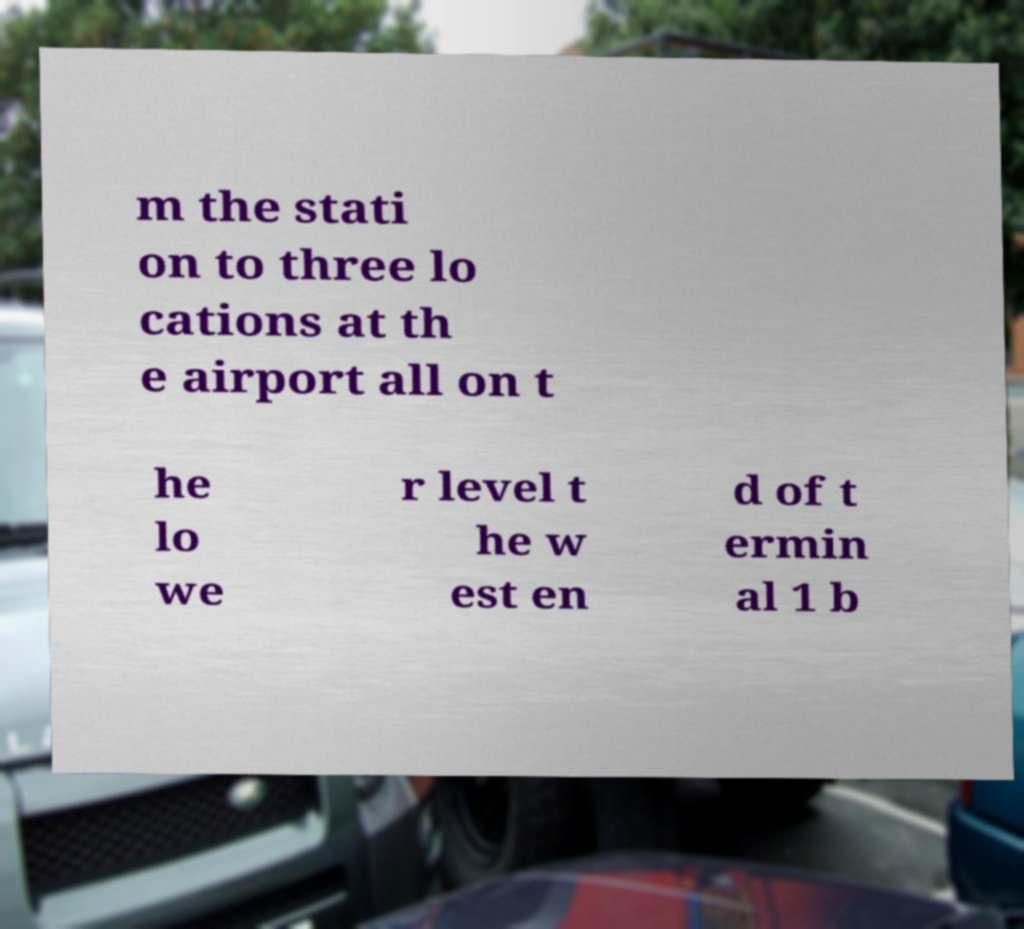Could you extract and type out the text from this image? m the stati on to three lo cations at th e airport all on t he lo we r level t he w est en d of t ermin al 1 b 